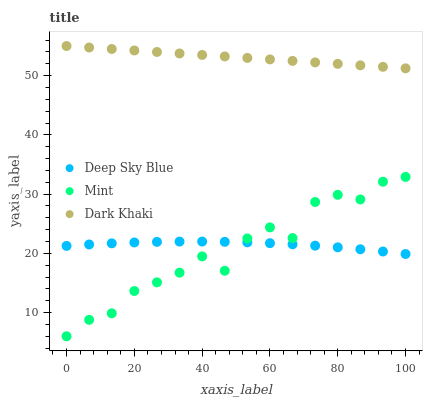Does Mint have the minimum area under the curve?
Answer yes or no. Yes. Does Dark Khaki have the maximum area under the curve?
Answer yes or no. Yes. Does Deep Sky Blue have the minimum area under the curve?
Answer yes or no. No. Does Deep Sky Blue have the maximum area under the curve?
Answer yes or no. No. Is Dark Khaki the smoothest?
Answer yes or no. Yes. Is Mint the roughest?
Answer yes or no. Yes. Is Deep Sky Blue the smoothest?
Answer yes or no. No. Is Deep Sky Blue the roughest?
Answer yes or no. No. Does Mint have the lowest value?
Answer yes or no. Yes. Does Deep Sky Blue have the lowest value?
Answer yes or no. No. Does Dark Khaki have the highest value?
Answer yes or no. Yes. Does Mint have the highest value?
Answer yes or no. No. Is Deep Sky Blue less than Dark Khaki?
Answer yes or no. Yes. Is Dark Khaki greater than Deep Sky Blue?
Answer yes or no. Yes. Does Mint intersect Deep Sky Blue?
Answer yes or no. Yes. Is Mint less than Deep Sky Blue?
Answer yes or no. No. Is Mint greater than Deep Sky Blue?
Answer yes or no. No. Does Deep Sky Blue intersect Dark Khaki?
Answer yes or no. No. 